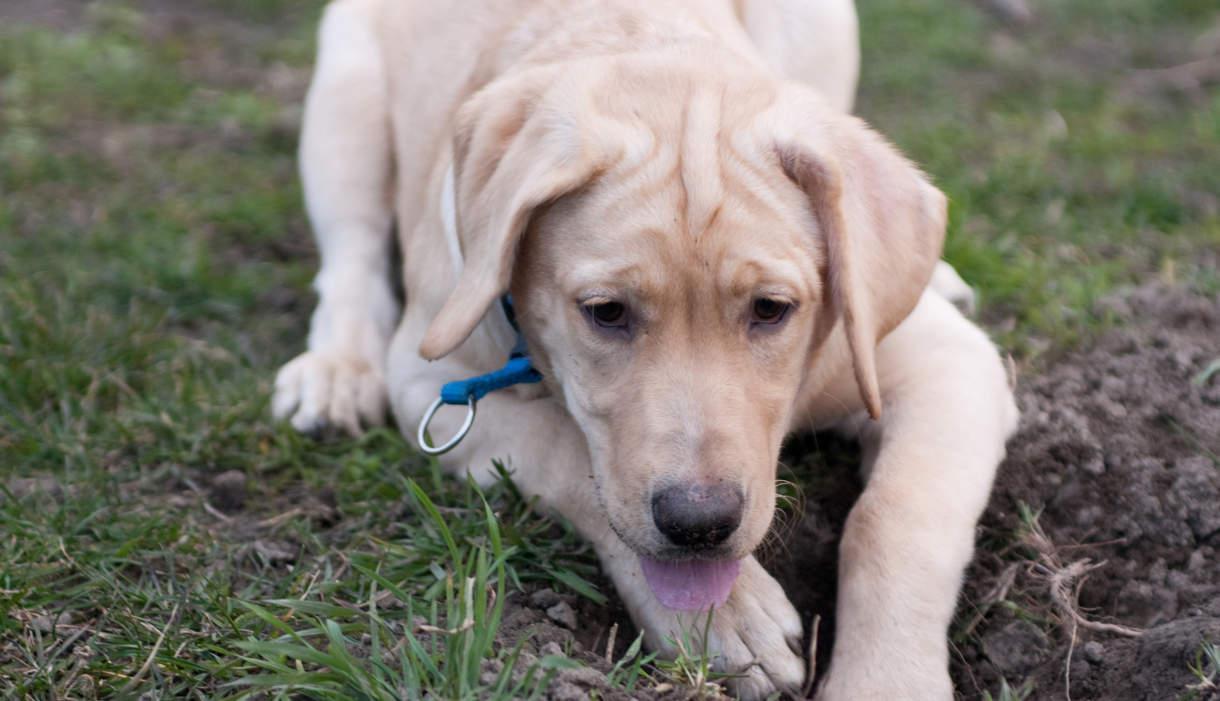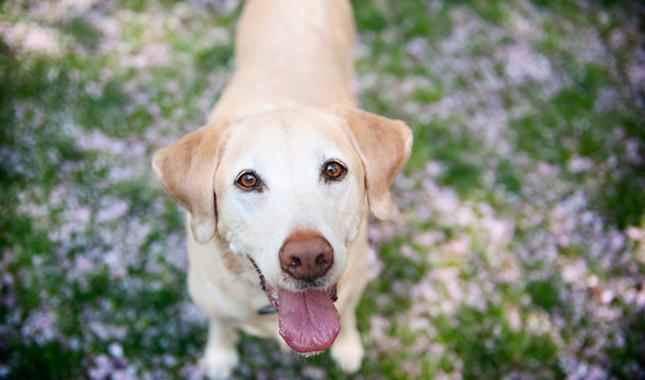The first image is the image on the left, the second image is the image on the right. For the images displayed, is the sentence "A ball sits on the grass in front of one of the dogs." factually correct? Answer yes or no. No. The first image is the image on the left, the second image is the image on the right. Analyze the images presented: Is the assertion "An image shows one dog in the grass with a ball." valid? Answer yes or no. No. 